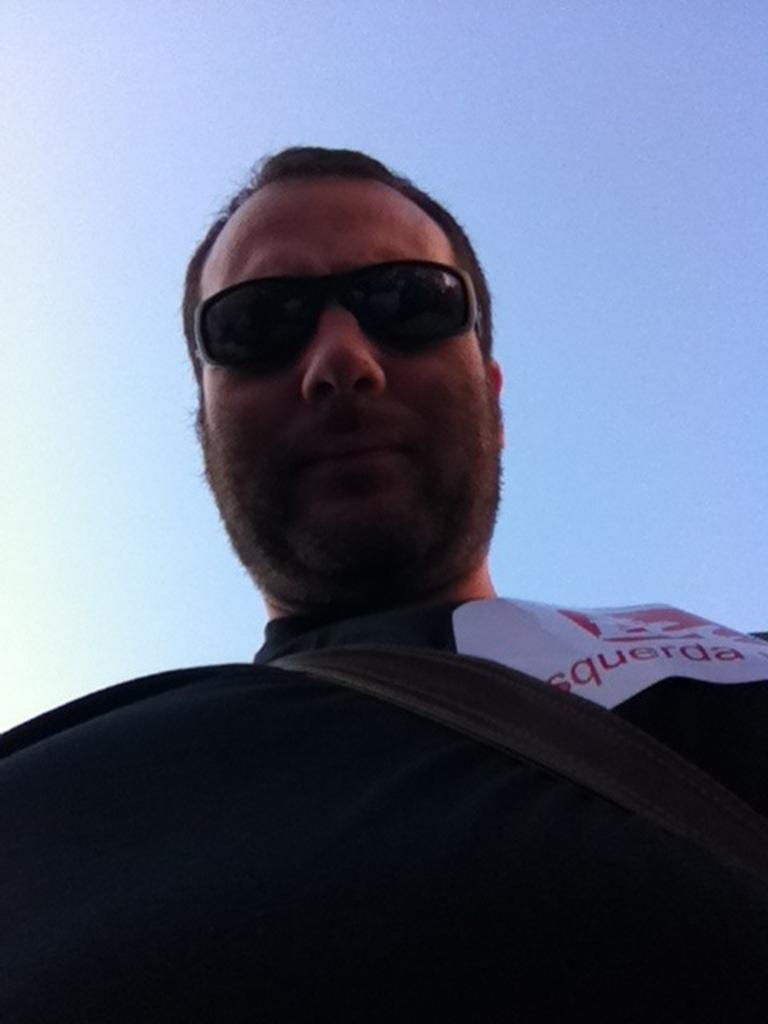Who is present in the image? There is a man in the image. What is the man wearing? The man is wearing a black t-shirt. What else can be seen on the man? The man has a bag strap and goggles. What can be seen in the background of the image? There is a sky visible in the image. What type of cup is the man holding in the image? There is no cup present in the image. Is there any grass visible in the image? There is no grass visible in the image; only the sky is mentioned as part of the background. 